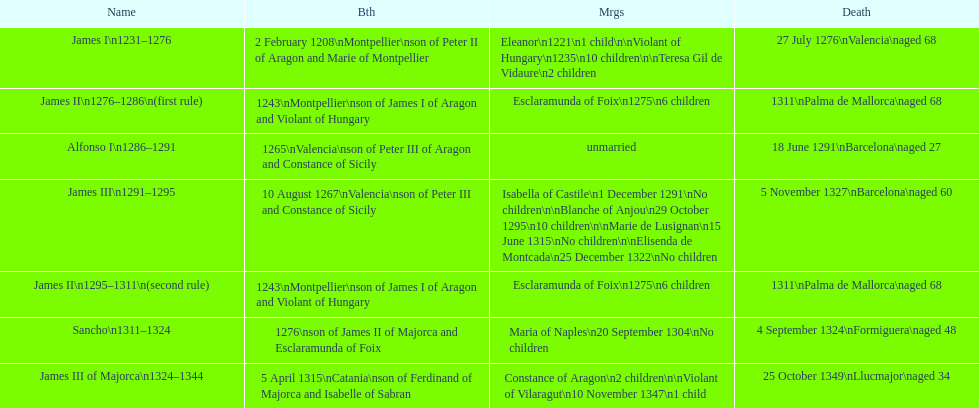What name is above james iii and below james ii? Alfonso I. Could you help me parse every detail presented in this table? {'header': ['Name', 'Bth', 'Mrgs', 'Death'], 'rows': [['James I\\n1231–1276', '2 February 1208\\nMontpellier\\nson of Peter II of Aragon and Marie of Montpellier', 'Eleanor\\n1221\\n1 child\\n\\nViolant of Hungary\\n1235\\n10 children\\n\\nTeresa Gil de Vidaure\\n2 children', '27 July 1276\\nValencia\\naged 68'], ['James II\\n1276–1286\\n(first rule)', '1243\\nMontpellier\\nson of James I of Aragon and Violant of Hungary', 'Esclaramunda of Foix\\n1275\\n6 children', '1311\\nPalma de Mallorca\\naged 68'], ['Alfonso I\\n1286–1291', '1265\\nValencia\\nson of Peter III of Aragon and Constance of Sicily', 'unmarried', '18 June 1291\\nBarcelona\\naged 27'], ['James III\\n1291–1295', '10 August 1267\\nValencia\\nson of Peter III and Constance of Sicily', 'Isabella of Castile\\n1 December 1291\\nNo children\\n\\nBlanche of Anjou\\n29 October 1295\\n10 children\\n\\nMarie de Lusignan\\n15 June 1315\\nNo children\\n\\nElisenda de Montcada\\n25 December 1322\\nNo children', '5 November 1327\\nBarcelona\\naged 60'], ['James II\\n1295–1311\\n(second rule)', '1243\\nMontpellier\\nson of James I of Aragon and Violant of Hungary', 'Esclaramunda of Foix\\n1275\\n6 children', '1311\\nPalma de Mallorca\\naged 68'], ['Sancho\\n1311–1324', '1276\\nson of James II of Majorca and Esclaramunda of Foix', 'Maria of Naples\\n20 September 1304\\nNo children', '4 September 1324\\nFormiguera\\naged 48'], ['James III of Majorca\\n1324–1344', '5 April 1315\\nCatania\\nson of Ferdinand of Majorca and Isabelle of Sabran', 'Constance of Aragon\\n2 children\\n\\nViolant of Vilaragut\\n10 November 1347\\n1 child', '25 October 1349\\nLlucmajor\\naged 34']]} 